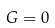Convert formula to latex. <formula><loc_0><loc_0><loc_500><loc_500>G = 0</formula> 